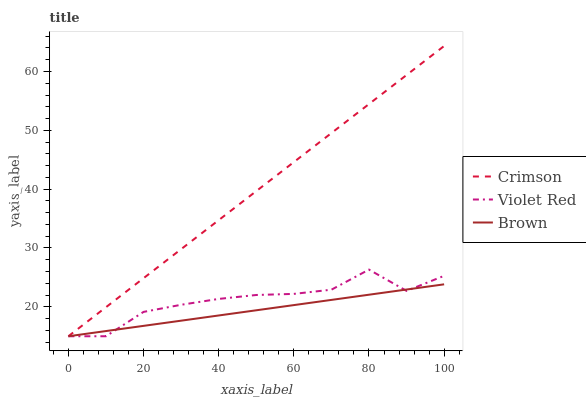Does Brown have the minimum area under the curve?
Answer yes or no. Yes. Does Crimson have the maximum area under the curve?
Answer yes or no. Yes. Does Violet Red have the minimum area under the curve?
Answer yes or no. No. Does Violet Red have the maximum area under the curve?
Answer yes or no. No. Is Crimson the smoothest?
Answer yes or no. Yes. Is Violet Red the roughest?
Answer yes or no. Yes. Is Brown the smoothest?
Answer yes or no. No. Is Brown the roughest?
Answer yes or no. No. Does Crimson have the lowest value?
Answer yes or no. Yes. Does Crimson have the highest value?
Answer yes or no. Yes. Does Violet Red have the highest value?
Answer yes or no. No. Does Crimson intersect Brown?
Answer yes or no. Yes. Is Crimson less than Brown?
Answer yes or no. No. Is Crimson greater than Brown?
Answer yes or no. No. 